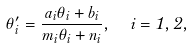Convert formula to latex. <formula><loc_0><loc_0><loc_500><loc_500>\theta ^ { \prime } _ { i } = \frac { a _ { i } \theta _ { i } + b _ { i } } { m _ { i } \theta _ { i } + n _ { i } } , \ \ i = 1 , 2 ,</formula> 